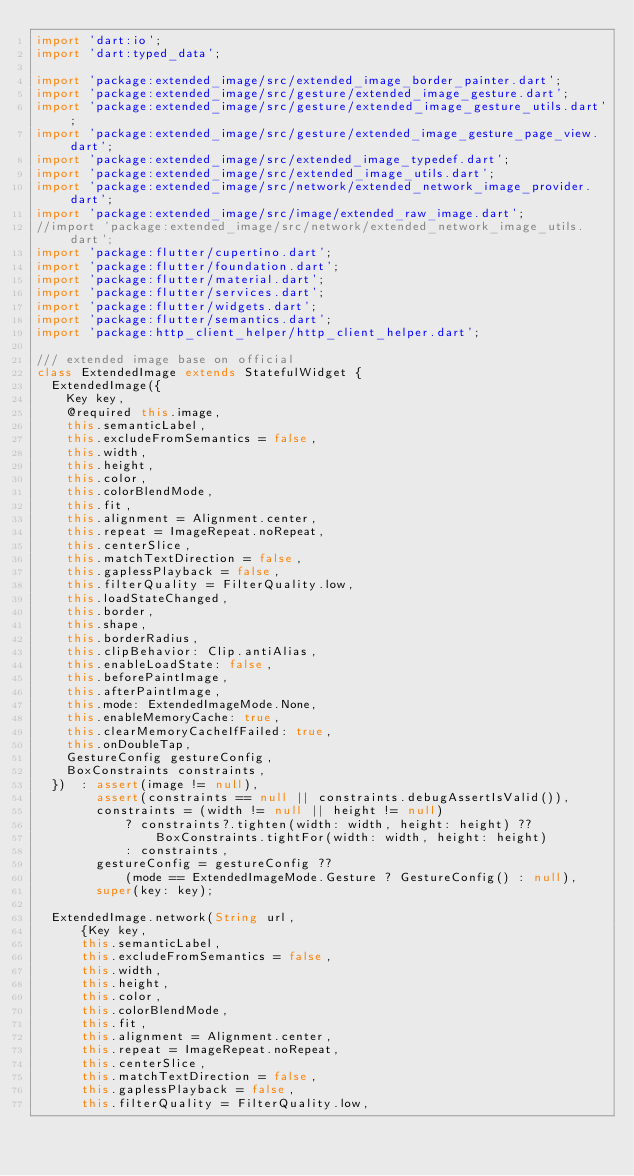<code> <loc_0><loc_0><loc_500><loc_500><_Dart_>import 'dart:io';
import 'dart:typed_data';

import 'package:extended_image/src/extended_image_border_painter.dart';
import 'package:extended_image/src/gesture/extended_image_gesture.dart';
import 'package:extended_image/src/gesture/extended_image_gesture_utils.dart';
import 'package:extended_image/src/gesture/extended_image_gesture_page_view.dart';
import 'package:extended_image/src/extended_image_typedef.dart';
import 'package:extended_image/src/extended_image_utils.dart';
import 'package:extended_image/src/network/extended_network_image_provider.dart';
import 'package:extended_image/src/image/extended_raw_image.dart';
//import 'package:extended_image/src/network/extended_network_image_utils.dart';
import 'package:flutter/cupertino.dart';
import 'package:flutter/foundation.dart';
import 'package:flutter/material.dart';
import 'package:flutter/services.dart';
import 'package:flutter/widgets.dart';
import 'package:flutter/semantics.dart';
import 'package:http_client_helper/http_client_helper.dart';

/// extended image base on official
class ExtendedImage extends StatefulWidget {
  ExtendedImage({
    Key key,
    @required this.image,
    this.semanticLabel,
    this.excludeFromSemantics = false,
    this.width,
    this.height,
    this.color,
    this.colorBlendMode,
    this.fit,
    this.alignment = Alignment.center,
    this.repeat = ImageRepeat.noRepeat,
    this.centerSlice,
    this.matchTextDirection = false,
    this.gaplessPlayback = false,
    this.filterQuality = FilterQuality.low,
    this.loadStateChanged,
    this.border,
    this.shape,
    this.borderRadius,
    this.clipBehavior: Clip.antiAlias,
    this.enableLoadState: false,
    this.beforePaintImage,
    this.afterPaintImage,
    this.mode: ExtendedImageMode.None,
    this.enableMemoryCache: true,
    this.clearMemoryCacheIfFailed: true,
    this.onDoubleTap,
    GestureConfig gestureConfig,
    BoxConstraints constraints,
  })  : assert(image != null),
        assert(constraints == null || constraints.debugAssertIsValid()),
        constraints = (width != null || height != null)
            ? constraints?.tighten(width: width, height: height) ??
                BoxConstraints.tightFor(width: width, height: height)
            : constraints,
        gestureConfig = gestureConfig ??
            (mode == ExtendedImageMode.Gesture ? GestureConfig() : null),
        super(key: key);

  ExtendedImage.network(String url,
      {Key key,
      this.semanticLabel,
      this.excludeFromSemantics = false,
      this.width,
      this.height,
      this.color,
      this.colorBlendMode,
      this.fit,
      this.alignment = Alignment.center,
      this.repeat = ImageRepeat.noRepeat,
      this.centerSlice,
      this.matchTextDirection = false,
      this.gaplessPlayback = false,
      this.filterQuality = FilterQuality.low,</code> 